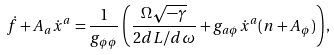Convert formula to latex. <formula><loc_0><loc_0><loc_500><loc_500>\dot { f } + A _ { a } \dot { x } ^ { a } = \frac { 1 } { g _ { \phi \phi } } \left ( \frac { \Omega \sqrt { - \gamma } } { 2 d L / d \omega } + g _ { a \phi } \dot { x } ^ { a } ( n + A _ { \phi } ) \right ) ,</formula> 